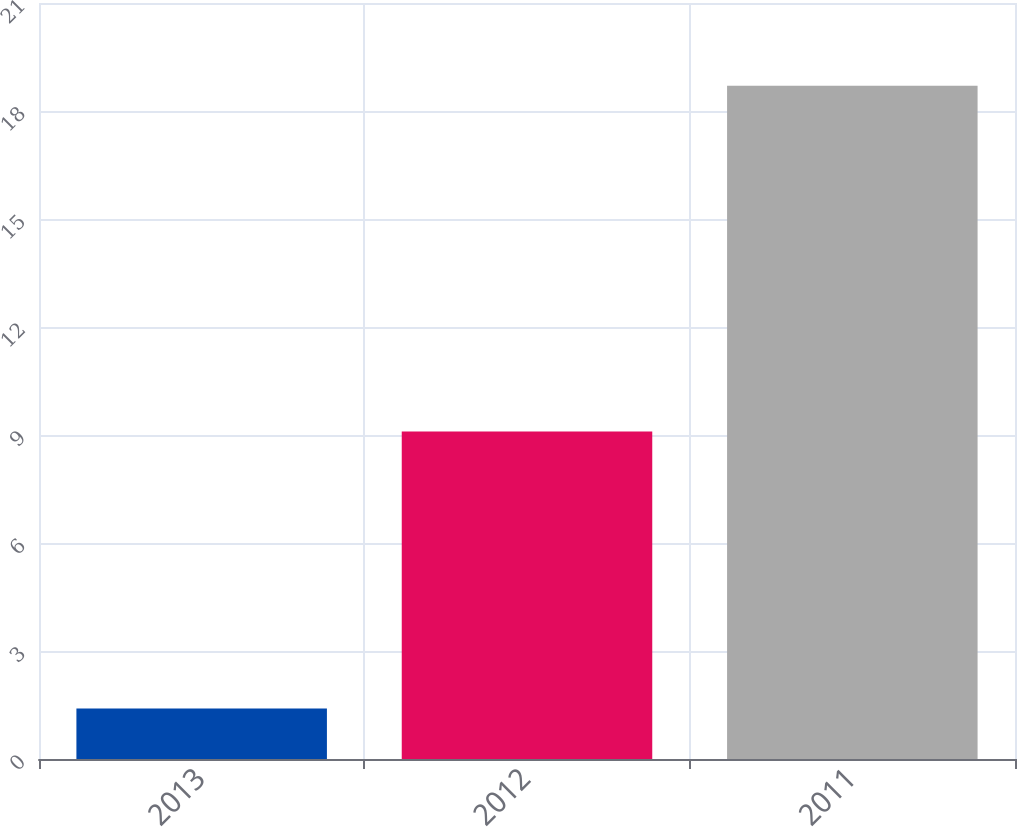<chart> <loc_0><loc_0><loc_500><loc_500><bar_chart><fcel>2013<fcel>2012<fcel>2011<nl><fcel>1.4<fcel>9.1<fcel>18.7<nl></chart> 